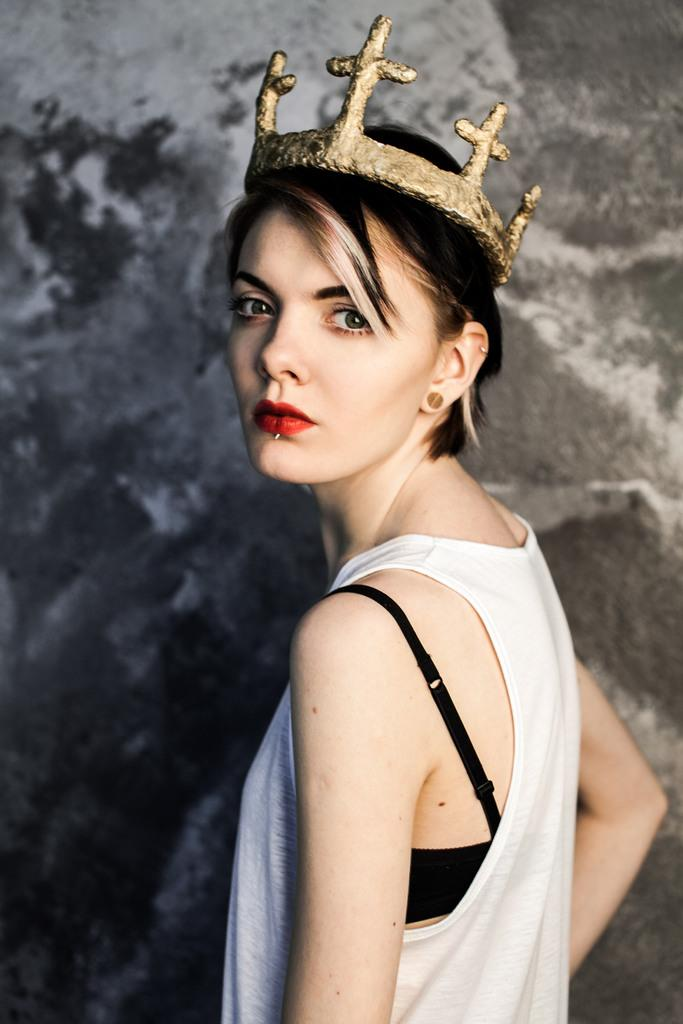Who or what is in the image? There is a person in the image. What is the person wearing? The person is wearing a crown. What can be seen behind the person? There is a wall behind the person. What type of vacation is the person planning based on the image? There is no information about a vacation in the image, as it only shows a person wearing a crown with a wall in the background. 